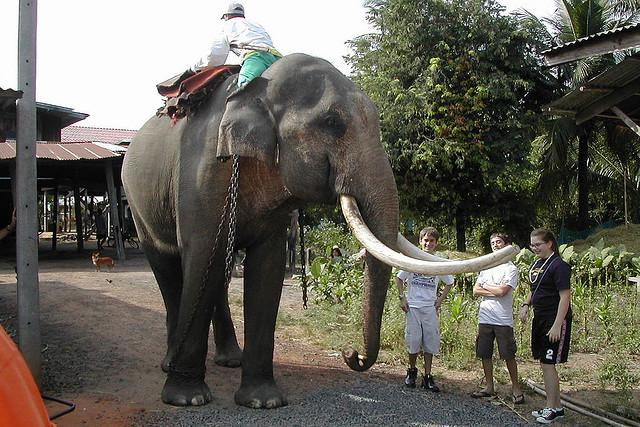What is the man on the elephant doing?
Keep it brief. Riding. Where are the tusks?
Give a very brief answer. On elephant. How many humans are the picture?
Concise answer only. 4. 